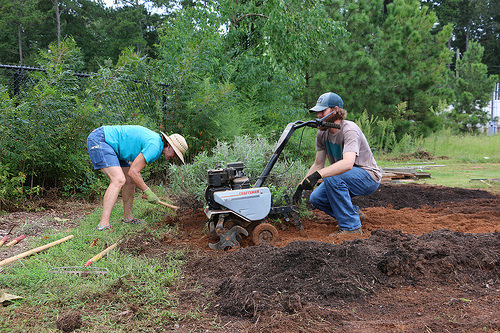<image>
Can you confirm if the man is behind the plant? No. The man is not behind the plant. From this viewpoint, the man appears to be positioned elsewhere in the scene. 